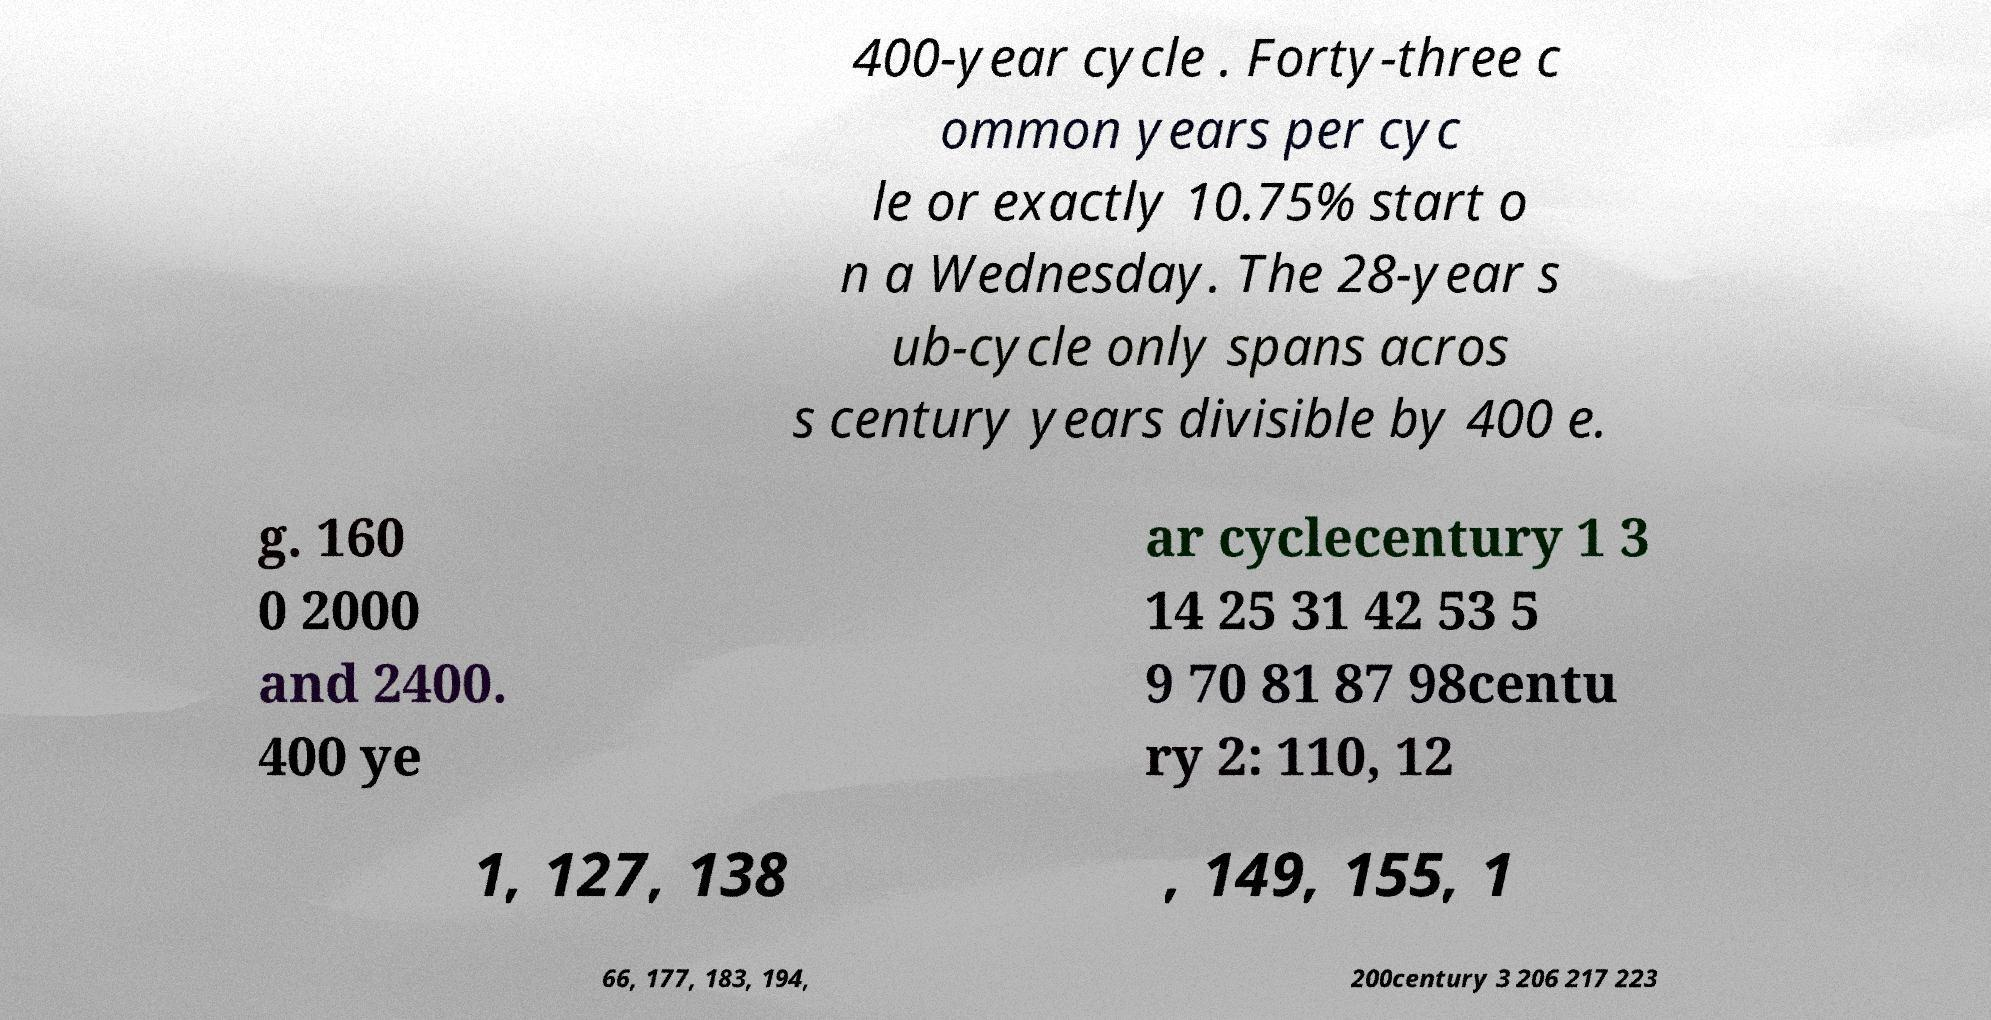Please read and relay the text visible in this image. What does it say? 400-year cycle . Forty-three c ommon years per cyc le or exactly 10.75% start o n a Wednesday. The 28-year s ub-cycle only spans acros s century years divisible by 400 e. g. 160 0 2000 and 2400. 400 ye ar cyclecentury 1 3 14 25 31 42 53 5 9 70 81 87 98centu ry 2: 110, 12 1, 127, 138 , 149, 155, 1 66, 177, 183, 194, 200century 3 206 217 223 